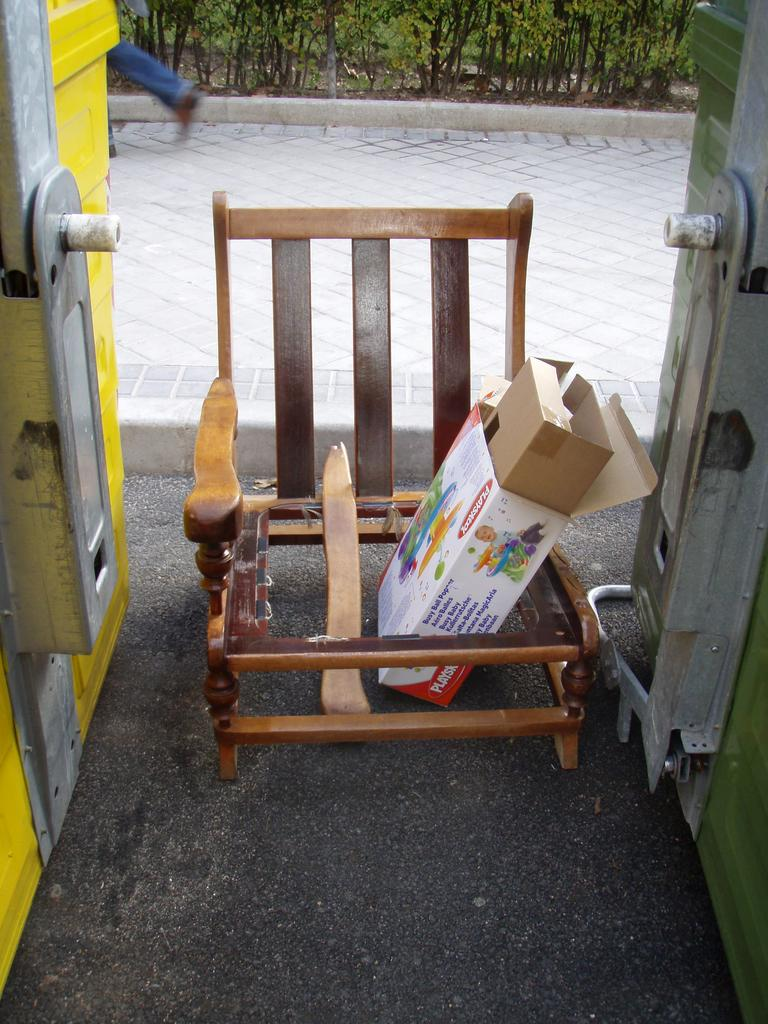Where was the image taken? The image was taken on the streets. What can be seen in the center of the image? There is a broken chair and boxes in the center of the image. What is visible in the background of the image? There is a walkway and plants in the background of the image. How much was the payment for the broken chair in the image? There is no information about payment in the image, as it only shows a broken chair and boxes on the streets. 